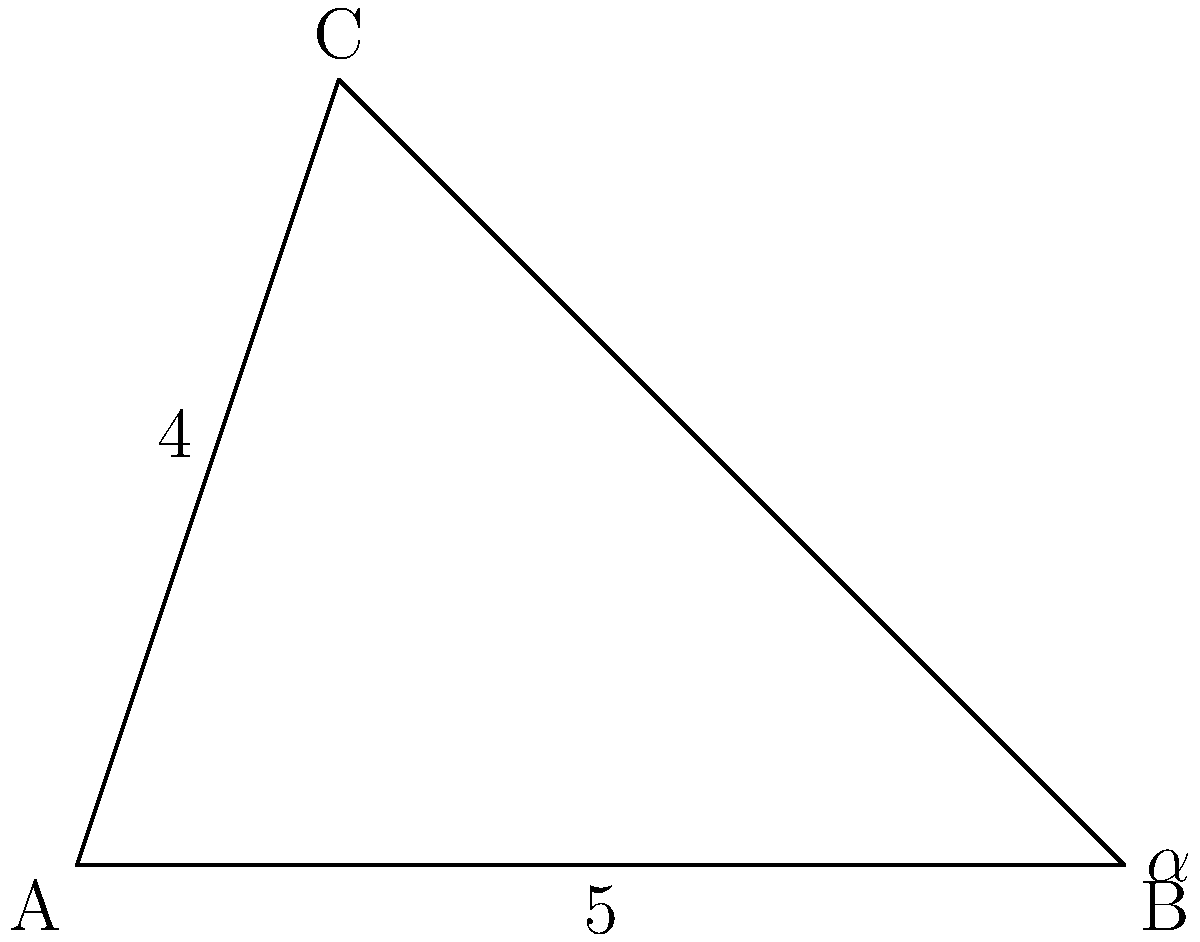As you plan your podcast series, you envision a triangle-shaped studio setup. Given a triangle ABC where side c = 5 units, side a = 4 units, and angle $\alpha$ (opposite side a) is 30°, find the measure of angle $\gamma$ (opposite side c). Use the law of sines to solve this problem, which could represent the optimal angle for your recording equipment placement. Let's solve this step-by-step using the law of sines:

1) The law of sines states that:
   $$\frac{a}{\sin A} = \frac{b}{\sin B} = \frac{c}{\sin C}$$

2) We know:
   - Side $a = 4$
   - Side $c = 5$
   - Angle $\alpha = 30°$
   - We need to find angle $\gamma$

3) Let's use the proportion:
   $$\frac{a}{\sin \alpha} = \frac{c}{\sin \gamma}$$

4) Substituting the known values:
   $$\frac{4}{\sin 30°} = \frac{5}{\sin \gamma}$$

5) Simplify:
   $$\frac{4}{0.5} = \frac{5}{\sin \gamma}$$

6) Solve for $\sin \gamma$:
   $$8 = \frac{5}{\sin \gamma}$$
   $$\sin \gamma = \frac{5}{8} = 0.625$$

7) To find $\gamma$, we need to take the inverse sine (arcsin):
   $$\gamma = \arcsin(0.625) \approx 38.68°$$

Therefore, angle $\gamma$ is approximately 38.68°.
Answer: $38.68°$ 